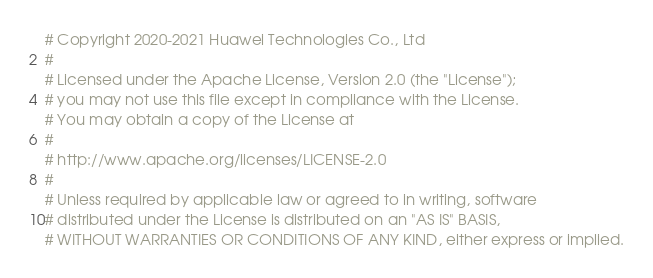Convert code to text. <code><loc_0><loc_0><loc_500><loc_500><_Python_># Copyright 2020-2021 Huawei Technologies Co., Ltd
#
# Licensed under the Apache License, Version 2.0 (the "License");
# you may not use this file except in compliance with the License.
# You may obtain a copy of the License at
#
# http://www.apache.org/licenses/LICENSE-2.0
#
# Unless required by applicable law or agreed to in writing, software
# distributed under the License is distributed on an "AS IS" BASIS,
# WITHOUT WARRANTIES OR CONDITIONS OF ANY KIND, either express or implied.</code> 